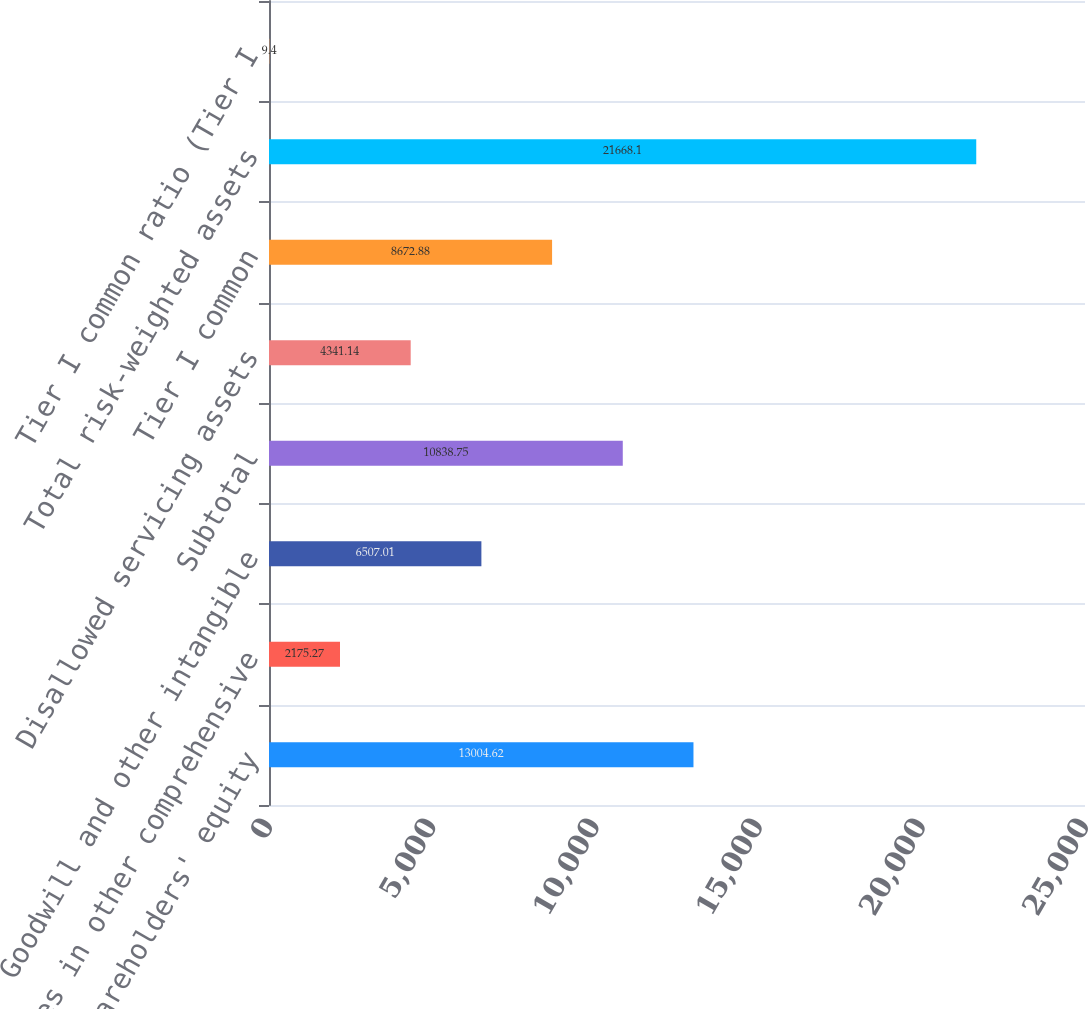<chart> <loc_0><loc_0><loc_500><loc_500><bar_chart><fcel>Shareholders' equity<fcel>Losses in other comprehensive<fcel>Goodwill and other intangible<fcel>Subtotal<fcel>Disallowed servicing assets<fcel>Tier I common<fcel>Total risk-weighted assets<fcel>Tier I common ratio (Tier I<nl><fcel>13004.6<fcel>2175.27<fcel>6507.01<fcel>10838.8<fcel>4341.14<fcel>8672.88<fcel>21668.1<fcel>9.4<nl></chart> 